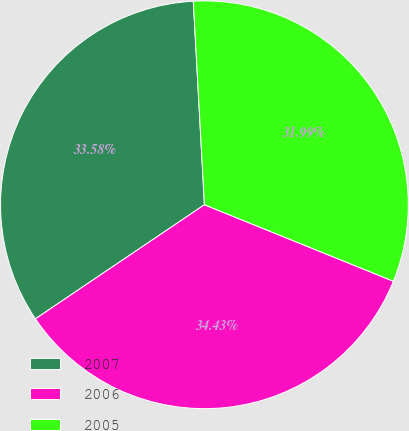<chart> <loc_0><loc_0><loc_500><loc_500><pie_chart><fcel>2007<fcel>2006<fcel>2005<nl><fcel>33.58%<fcel>34.43%<fcel>31.99%<nl></chart> 